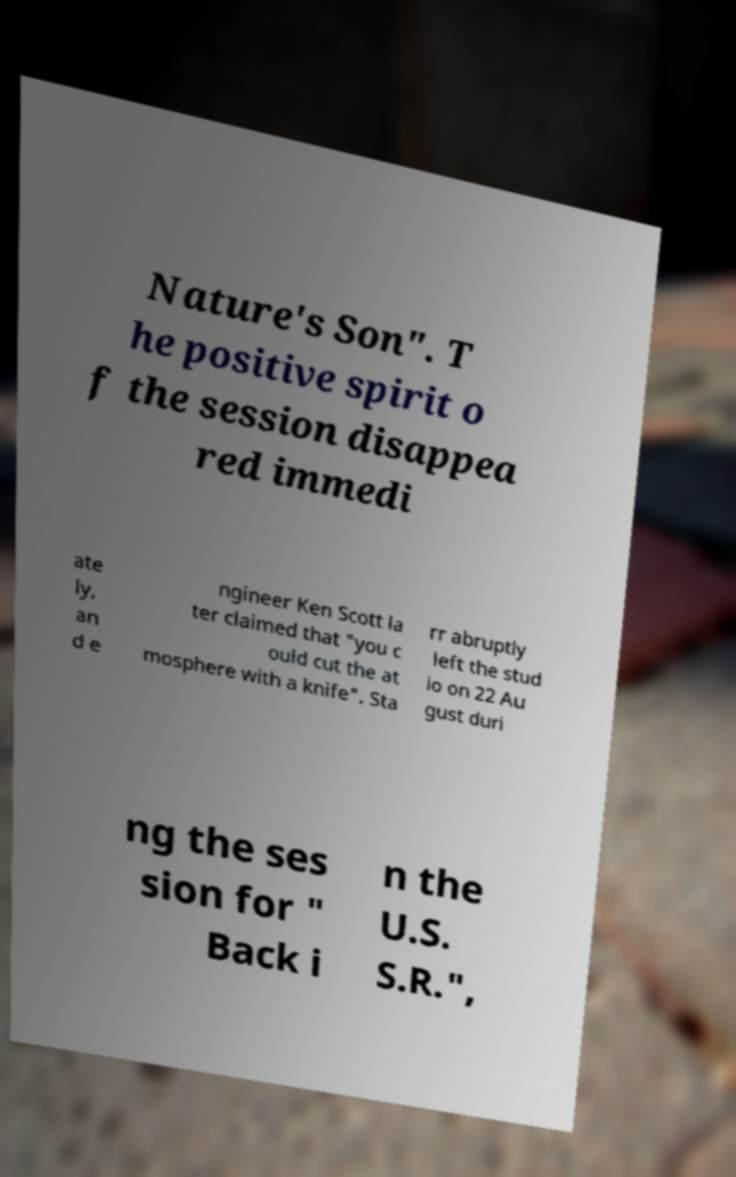Can you accurately transcribe the text from the provided image for me? Nature's Son". T he positive spirit o f the session disappea red immedi ate ly, an d e ngineer Ken Scott la ter claimed that "you c ould cut the at mosphere with a knife". Sta rr abruptly left the stud io on 22 Au gust duri ng the ses sion for " Back i n the U.S. S.R.", 